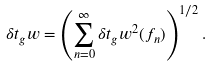Convert formula to latex. <formula><loc_0><loc_0><loc_500><loc_500>\delta t _ { g } w = \left ( \sum _ { n = 0 } ^ { \infty } \delta t _ { g } w ^ { 2 } ( f _ { n } ) \right ) ^ { 1 / 2 } .</formula> 